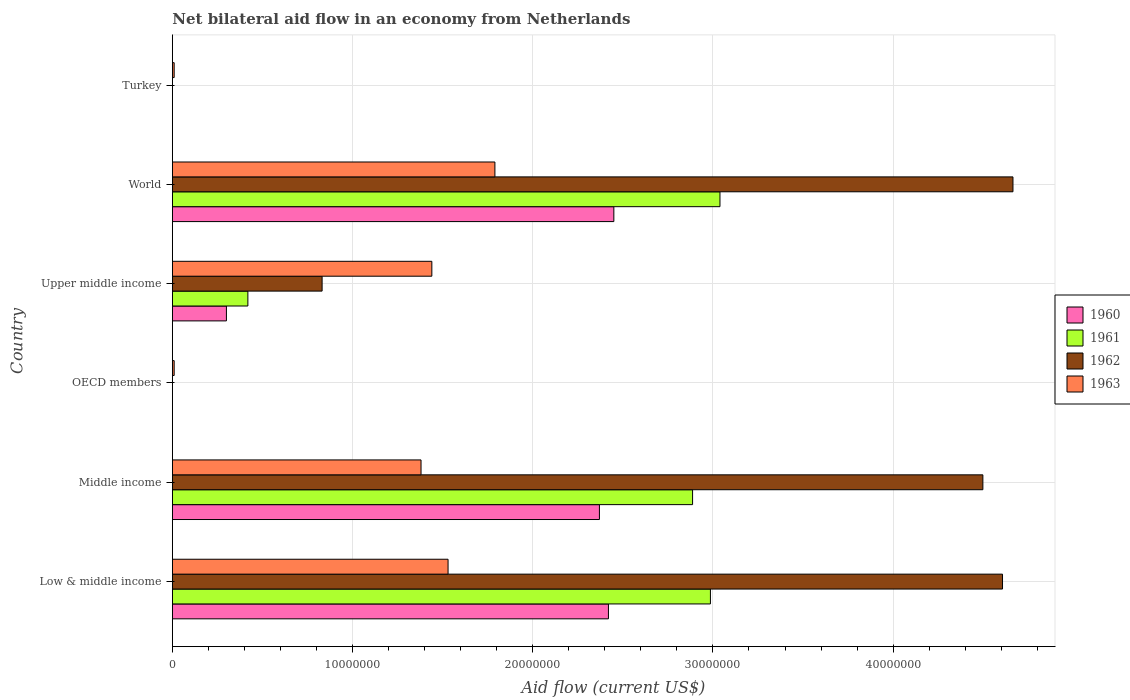Are the number of bars per tick equal to the number of legend labels?
Provide a succinct answer. No. Are the number of bars on each tick of the Y-axis equal?
Offer a terse response. No. How many bars are there on the 4th tick from the top?
Your answer should be compact. 1. How many bars are there on the 1st tick from the bottom?
Your answer should be very brief. 4. What is the label of the 4th group of bars from the top?
Offer a very short reply. OECD members. What is the net bilateral aid flow in 1963 in Turkey?
Provide a short and direct response. 1.00e+05. Across all countries, what is the maximum net bilateral aid flow in 1961?
Make the answer very short. 3.04e+07. What is the total net bilateral aid flow in 1962 in the graph?
Ensure brevity in your answer.  1.46e+08. What is the difference between the net bilateral aid flow in 1961 in Low & middle income and that in Upper middle income?
Offer a very short reply. 2.57e+07. What is the difference between the net bilateral aid flow in 1961 in Turkey and the net bilateral aid flow in 1963 in Middle income?
Keep it short and to the point. -1.38e+07. What is the average net bilateral aid flow in 1962 per country?
Offer a terse response. 2.43e+07. What is the difference between the net bilateral aid flow in 1960 and net bilateral aid flow in 1962 in World?
Provide a succinct answer. -2.22e+07. What is the ratio of the net bilateral aid flow in 1963 in Low & middle income to that in Turkey?
Offer a very short reply. 153. Is the net bilateral aid flow in 1963 in OECD members less than that in Upper middle income?
Provide a short and direct response. Yes. Is the difference between the net bilateral aid flow in 1960 in Middle income and Upper middle income greater than the difference between the net bilateral aid flow in 1962 in Middle income and Upper middle income?
Provide a short and direct response. No. What is the difference between the highest and the second highest net bilateral aid flow in 1963?
Provide a succinct answer. 2.60e+06. What is the difference between the highest and the lowest net bilateral aid flow in 1960?
Your answer should be very brief. 2.45e+07. In how many countries, is the net bilateral aid flow in 1962 greater than the average net bilateral aid flow in 1962 taken over all countries?
Give a very brief answer. 3. Is it the case that in every country, the sum of the net bilateral aid flow in 1963 and net bilateral aid flow in 1962 is greater than the sum of net bilateral aid flow in 1961 and net bilateral aid flow in 1960?
Offer a very short reply. No. How many bars are there?
Give a very brief answer. 18. How many countries are there in the graph?
Provide a short and direct response. 6. What is the difference between two consecutive major ticks on the X-axis?
Your answer should be compact. 1.00e+07. How many legend labels are there?
Make the answer very short. 4. What is the title of the graph?
Provide a succinct answer. Net bilateral aid flow in an economy from Netherlands. Does "2013" appear as one of the legend labels in the graph?
Keep it short and to the point. No. What is the label or title of the Y-axis?
Provide a short and direct response. Country. What is the Aid flow (current US$) in 1960 in Low & middle income?
Ensure brevity in your answer.  2.42e+07. What is the Aid flow (current US$) of 1961 in Low & middle income?
Make the answer very short. 2.99e+07. What is the Aid flow (current US$) of 1962 in Low & middle income?
Offer a terse response. 4.61e+07. What is the Aid flow (current US$) in 1963 in Low & middle income?
Make the answer very short. 1.53e+07. What is the Aid flow (current US$) in 1960 in Middle income?
Your response must be concise. 2.37e+07. What is the Aid flow (current US$) of 1961 in Middle income?
Give a very brief answer. 2.89e+07. What is the Aid flow (current US$) in 1962 in Middle income?
Ensure brevity in your answer.  4.50e+07. What is the Aid flow (current US$) in 1963 in Middle income?
Give a very brief answer. 1.38e+07. What is the Aid flow (current US$) in 1960 in OECD members?
Ensure brevity in your answer.  0. What is the Aid flow (current US$) in 1963 in OECD members?
Provide a succinct answer. 1.00e+05. What is the Aid flow (current US$) in 1961 in Upper middle income?
Provide a succinct answer. 4.19e+06. What is the Aid flow (current US$) of 1962 in Upper middle income?
Your answer should be compact. 8.31e+06. What is the Aid flow (current US$) of 1963 in Upper middle income?
Your answer should be compact. 1.44e+07. What is the Aid flow (current US$) in 1960 in World?
Your answer should be very brief. 2.45e+07. What is the Aid flow (current US$) in 1961 in World?
Offer a very short reply. 3.04e+07. What is the Aid flow (current US$) in 1962 in World?
Give a very brief answer. 4.66e+07. What is the Aid flow (current US$) of 1963 in World?
Provide a short and direct response. 1.79e+07. What is the Aid flow (current US$) of 1960 in Turkey?
Keep it short and to the point. 0. Across all countries, what is the maximum Aid flow (current US$) in 1960?
Offer a terse response. 2.45e+07. Across all countries, what is the maximum Aid flow (current US$) in 1961?
Your response must be concise. 3.04e+07. Across all countries, what is the maximum Aid flow (current US$) of 1962?
Your answer should be very brief. 4.66e+07. Across all countries, what is the maximum Aid flow (current US$) in 1963?
Provide a short and direct response. 1.79e+07. Across all countries, what is the minimum Aid flow (current US$) of 1961?
Keep it short and to the point. 0. Across all countries, what is the minimum Aid flow (current US$) in 1962?
Your answer should be compact. 0. What is the total Aid flow (current US$) of 1960 in the graph?
Your answer should be compact. 7.54e+07. What is the total Aid flow (current US$) of 1961 in the graph?
Give a very brief answer. 9.33e+07. What is the total Aid flow (current US$) of 1962 in the graph?
Your answer should be very brief. 1.46e+08. What is the total Aid flow (current US$) in 1963 in the graph?
Provide a short and direct response. 6.16e+07. What is the difference between the Aid flow (current US$) of 1960 in Low & middle income and that in Middle income?
Ensure brevity in your answer.  5.00e+05. What is the difference between the Aid flow (current US$) in 1961 in Low & middle income and that in Middle income?
Make the answer very short. 9.90e+05. What is the difference between the Aid flow (current US$) of 1962 in Low & middle income and that in Middle income?
Make the answer very short. 1.09e+06. What is the difference between the Aid flow (current US$) of 1963 in Low & middle income and that in Middle income?
Your response must be concise. 1.50e+06. What is the difference between the Aid flow (current US$) of 1963 in Low & middle income and that in OECD members?
Provide a succinct answer. 1.52e+07. What is the difference between the Aid flow (current US$) in 1960 in Low & middle income and that in Upper middle income?
Ensure brevity in your answer.  2.12e+07. What is the difference between the Aid flow (current US$) of 1961 in Low & middle income and that in Upper middle income?
Offer a terse response. 2.57e+07. What is the difference between the Aid flow (current US$) of 1962 in Low & middle income and that in Upper middle income?
Offer a very short reply. 3.78e+07. What is the difference between the Aid flow (current US$) in 1960 in Low & middle income and that in World?
Keep it short and to the point. -3.00e+05. What is the difference between the Aid flow (current US$) of 1961 in Low & middle income and that in World?
Make the answer very short. -5.30e+05. What is the difference between the Aid flow (current US$) of 1962 in Low & middle income and that in World?
Provide a short and direct response. -5.80e+05. What is the difference between the Aid flow (current US$) in 1963 in Low & middle income and that in World?
Give a very brief answer. -2.60e+06. What is the difference between the Aid flow (current US$) in 1963 in Low & middle income and that in Turkey?
Offer a very short reply. 1.52e+07. What is the difference between the Aid flow (current US$) in 1963 in Middle income and that in OECD members?
Your answer should be very brief. 1.37e+07. What is the difference between the Aid flow (current US$) of 1960 in Middle income and that in Upper middle income?
Your answer should be very brief. 2.07e+07. What is the difference between the Aid flow (current US$) in 1961 in Middle income and that in Upper middle income?
Offer a terse response. 2.47e+07. What is the difference between the Aid flow (current US$) of 1962 in Middle income and that in Upper middle income?
Your answer should be very brief. 3.67e+07. What is the difference between the Aid flow (current US$) in 1963 in Middle income and that in Upper middle income?
Your response must be concise. -6.00e+05. What is the difference between the Aid flow (current US$) of 1960 in Middle income and that in World?
Give a very brief answer. -8.00e+05. What is the difference between the Aid flow (current US$) in 1961 in Middle income and that in World?
Ensure brevity in your answer.  -1.52e+06. What is the difference between the Aid flow (current US$) in 1962 in Middle income and that in World?
Keep it short and to the point. -1.67e+06. What is the difference between the Aid flow (current US$) of 1963 in Middle income and that in World?
Provide a short and direct response. -4.10e+06. What is the difference between the Aid flow (current US$) in 1963 in Middle income and that in Turkey?
Your answer should be very brief. 1.37e+07. What is the difference between the Aid flow (current US$) of 1963 in OECD members and that in Upper middle income?
Ensure brevity in your answer.  -1.43e+07. What is the difference between the Aid flow (current US$) in 1963 in OECD members and that in World?
Your answer should be very brief. -1.78e+07. What is the difference between the Aid flow (current US$) of 1963 in OECD members and that in Turkey?
Keep it short and to the point. 0. What is the difference between the Aid flow (current US$) in 1960 in Upper middle income and that in World?
Your response must be concise. -2.15e+07. What is the difference between the Aid flow (current US$) in 1961 in Upper middle income and that in World?
Offer a very short reply. -2.62e+07. What is the difference between the Aid flow (current US$) of 1962 in Upper middle income and that in World?
Make the answer very short. -3.83e+07. What is the difference between the Aid flow (current US$) in 1963 in Upper middle income and that in World?
Provide a succinct answer. -3.50e+06. What is the difference between the Aid flow (current US$) in 1963 in Upper middle income and that in Turkey?
Provide a short and direct response. 1.43e+07. What is the difference between the Aid flow (current US$) in 1963 in World and that in Turkey?
Your response must be concise. 1.78e+07. What is the difference between the Aid flow (current US$) in 1960 in Low & middle income and the Aid flow (current US$) in 1961 in Middle income?
Make the answer very short. -4.67e+06. What is the difference between the Aid flow (current US$) of 1960 in Low & middle income and the Aid flow (current US$) of 1962 in Middle income?
Provide a short and direct response. -2.08e+07. What is the difference between the Aid flow (current US$) of 1960 in Low & middle income and the Aid flow (current US$) of 1963 in Middle income?
Provide a short and direct response. 1.04e+07. What is the difference between the Aid flow (current US$) in 1961 in Low & middle income and the Aid flow (current US$) in 1962 in Middle income?
Your answer should be compact. -1.51e+07. What is the difference between the Aid flow (current US$) in 1961 in Low & middle income and the Aid flow (current US$) in 1963 in Middle income?
Keep it short and to the point. 1.61e+07. What is the difference between the Aid flow (current US$) in 1962 in Low & middle income and the Aid flow (current US$) in 1963 in Middle income?
Offer a very short reply. 3.23e+07. What is the difference between the Aid flow (current US$) in 1960 in Low & middle income and the Aid flow (current US$) in 1963 in OECD members?
Your response must be concise. 2.41e+07. What is the difference between the Aid flow (current US$) of 1961 in Low & middle income and the Aid flow (current US$) of 1963 in OECD members?
Provide a succinct answer. 2.98e+07. What is the difference between the Aid flow (current US$) of 1962 in Low & middle income and the Aid flow (current US$) of 1963 in OECD members?
Your response must be concise. 4.60e+07. What is the difference between the Aid flow (current US$) in 1960 in Low & middle income and the Aid flow (current US$) in 1961 in Upper middle income?
Make the answer very short. 2.00e+07. What is the difference between the Aid flow (current US$) of 1960 in Low & middle income and the Aid flow (current US$) of 1962 in Upper middle income?
Keep it short and to the point. 1.59e+07. What is the difference between the Aid flow (current US$) in 1960 in Low & middle income and the Aid flow (current US$) in 1963 in Upper middle income?
Your answer should be compact. 9.80e+06. What is the difference between the Aid flow (current US$) of 1961 in Low & middle income and the Aid flow (current US$) of 1962 in Upper middle income?
Offer a very short reply. 2.16e+07. What is the difference between the Aid flow (current US$) in 1961 in Low & middle income and the Aid flow (current US$) in 1963 in Upper middle income?
Keep it short and to the point. 1.55e+07. What is the difference between the Aid flow (current US$) of 1962 in Low & middle income and the Aid flow (current US$) of 1963 in Upper middle income?
Offer a very short reply. 3.17e+07. What is the difference between the Aid flow (current US$) of 1960 in Low & middle income and the Aid flow (current US$) of 1961 in World?
Offer a terse response. -6.19e+06. What is the difference between the Aid flow (current US$) in 1960 in Low & middle income and the Aid flow (current US$) in 1962 in World?
Provide a short and direct response. -2.24e+07. What is the difference between the Aid flow (current US$) of 1960 in Low & middle income and the Aid flow (current US$) of 1963 in World?
Ensure brevity in your answer.  6.30e+06. What is the difference between the Aid flow (current US$) in 1961 in Low & middle income and the Aid flow (current US$) in 1962 in World?
Ensure brevity in your answer.  -1.68e+07. What is the difference between the Aid flow (current US$) in 1961 in Low & middle income and the Aid flow (current US$) in 1963 in World?
Your answer should be compact. 1.20e+07. What is the difference between the Aid flow (current US$) in 1962 in Low & middle income and the Aid flow (current US$) in 1963 in World?
Offer a very short reply. 2.82e+07. What is the difference between the Aid flow (current US$) of 1960 in Low & middle income and the Aid flow (current US$) of 1963 in Turkey?
Ensure brevity in your answer.  2.41e+07. What is the difference between the Aid flow (current US$) of 1961 in Low & middle income and the Aid flow (current US$) of 1963 in Turkey?
Your response must be concise. 2.98e+07. What is the difference between the Aid flow (current US$) in 1962 in Low & middle income and the Aid flow (current US$) in 1963 in Turkey?
Your answer should be compact. 4.60e+07. What is the difference between the Aid flow (current US$) in 1960 in Middle income and the Aid flow (current US$) in 1963 in OECD members?
Keep it short and to the point. 2.36e+07. What is the difference between the Aid flow (current US$) in 1961 in Middle income and the Aid flow (current US$) in 1963 in OECD members?
Keep it short and to the point. 2.88e+07. What is the difference between the Aid flow (current US$) in 1962 in Middle income and the Aid flow (current US$) in 1963 in OECD members?
Your answer should be compact. 4.49e+07. What is the difference between the Aid flow (current US$) in 1960 in Middle income and the Aid flow (current US$) in 1961 in Upper middle income?
Provide a succinct answer. 1.95e+07. What is the difference between the Aid flow (current US$) of 1960 in Middle income and the Aid flow (current US$) of 1962 in Upper middle income?
Provide a short and direct response. 1.54e+07. What is the difference between the Aid flow (current US$) of 1960 in Middle income and the Aid flow (current US$) of 1963 in Upper middle income?
Your answer should be compact. 9.30e+06. What is the difference between the Aid flow (current US$) in 1961 in Middle income and the Aid flow (current US$) in 1962 in Upper middle income?
Your answer should be very brief. 2.06e+07. What is the difference between the Aid flow (current US$) of 1961 in Middle income and the Aid flow (current US$) of 1963 in Upper middle income?
Make the answer very short. 1.45e+07. What is the difference between the Aid flow (current US$) of 1962 in Middle income and the Aid flow (current US$) of 1963 in Upper middle income?
Your answer should be compact. 3.06e+07. What is the difference between the Aid flow (current US$) in 1960 in Middle income and the Aid flow (current US$) in 1961 in World?
Your answer should be compact. -6.69e+06. What is the difference between the Aid flow (current US$) in 1960 in Middle income and the Aid flow (current US$) in 1962 in World?
Offer a terse response. -2.30e+07. What is the difference between the Aid flow (current US$) in 1960 in Middle income and the Aid flow (current US$) in 1963 in World?
Make the answer very short. 5.80e+06. What is the difference between the Aid flow (current US$) in 1961 in Middle income and the Aid flow (current US$) in 1962 in World?
Make the answer very short. -1.78e+07. What is the difference between the Aid flow (current US$) of 1961 in Middle income and the Aid flow (current US$) of 1963 in World?
Make the answer very short. 1.10e+07. What is the difference between the Aid flow (current US$) in 1962 in Middle income and the Aid flow (current US$) in 1963 in World?
Give a very brief answer. 2.71e+07. What is the difference between the Aid flow (current US$) in 1960 in Middle income and the Aid flow (current US$) in 1963 in Turkey?
Your response must be concise. 2.36e+07. What is the difference between the Aid flow (current US$) in 1961 in Middle income and the Aid flow (current US$) in 1963 in Turkey?
Provide a short and direct response. 2.88e+07. What is the difference between the Aid flow (current US$) in 1962 in Middle income and the Aid flow (current US$) in 1963 in Turkey?
Provide a succinct answer. 4.49e+07. What is the difference between the Aid flow (current US$) of 1960 in Upper middle income and the Aid flow (current US$) of 1961 in World?
Make the answer very short. -2.74e+07. What is the difference between the Aid flow (current US$) in 1960 in Upper middle income and the Aid flow (current US$) in 1962 in World?
Offer a very short reply. -4.36e+07. What is the difference between the Aid flow (current US$) of 1960 in Upper middle income and the Aid flow (current US$) of 1963 in World?
Your response must be concise. -1.49e+07. What is the difference between the Aid flow (current US$) in 1961 in Upper middle income and the Aid flow (current US$) in 1962 in World?
Offer a very short reply. -4.25e+07. What is the difference between the Aid flow (current US$) in 1961 in Upper middle income and the Aid flow (current US$) in 1963 in World?
Keep it short and to the point. -1.37e+07. What is the difference between the Aid flow (current US$) in 1962 in Upper middle income and the Aid flow (current US$) in 1963 in World?
Ensure brevity in your answer.  -9.59e+06. What is the difference between the Aid flow (current US$) in 1960 in Upper middle income and the Aid flow (current US$) in 1963 in Turkey?
Ensure brevity in your answer.  2.90e+06. What is the difference between the Aid flow (current US$) of 1961 in Upper middle income and the Aid flow (current US$) of 1963 in Turkey?
Make the answer very short. 4.09e+06. What is the difference between the Aid flow (current US$) in 1962 in Upper middle income and the Aid flow (current US$) in 1963 in Turkey?
Keep it short and to the point. 8.21e+06. What is the difference between the Aid flow (current US$) in 1960 in World and the Aid flow (current US$) in 1963 in Turkey?
Keep it short and to the point. 2.44e+07. What is the difference between the Aid flow (current US$) in 1961 in World and the Aid flow (current US$) in 1963 in Turkey?
Offer a terse response. 3.03e+07. What is the difference between the Aid flow (current US$) of 1962 in World and the Aid flow (current US$) of 1963 in Turkey?
Your response must be concise. 4.66e+07. What is the average Aid flow (current US$) of 1960 per country?
Provide a short and direct response. 1.26e+07. What is the average Aid flow (current US$) of 1961 per country?
Your answer should be very brief. 1.56e+07. What is the average Aid flow (current US$) of 1962 per country?
Make the answer very short. 2.43e+07. What is the average Aid flow (current US$) in 1963 per country?
Give a very brief answer. 1.03e+07. What is the difference between the Aid flow (current US$) in 1960 and Aid flow (current US$) in 1961 in Low & middle income?
Provide a succinct answer. -5.66e+06. What is the difference between the Aid flow (current US$) in 1960 and Aid flow (current US$) in 1962 in Low & middle income?
Your answer should be compact. -2.19e+07. What is the difference between the Aid flow (current US$) of 1960 and Aid flow (current US$) of 1963 in Low & middle income?
Make the answer very short. 8.90e+06. What is the difference between the Aid flow (current US$) in 1961 and Aid flow (current US$) in 1962 in Low & middle income?
Give a very brief answer. -1.62e+07. What is the difference between the Aid flow (current US$) of 1961 and Aid flow (current US$) of 1963 in Low & middle income?
Offer a very short reply. 1.46e+07. What is the difference between the Aid flow (current US$) of 1962 and Aid flow (current US$) of 1963 in Low & middle income?
Provide a short and direct response. 3.08e+07. What is the difference between the Aid flow (current US$) in 1960 and Aid flow (current US$) in 1961 in Middle income?
Offer a very short reply. -5.17e+06. What is the difference between the Aid flow (current US$) of 1960 and Aid flow (current US$) of 1962 in Middle income?
Your answer should be very brief. -2.13e+07. What is the difference between the Aid flow (current US$) of 1960 and Aid flow (current US$) of 1963 in Middle income?
Provide a short and direct response. 9.90e+06. What is the difference between the Aid flow (current US$) of 1961 and Aid flow (current US$) of 1962 in Middle income?
Offer a very short reply. -1.61e+07. What is the difference between the Aid flow (current US$) in 1961 and Aid flow (current US$) in 1963 in Middle income?
Provide a short and direct response. 1.51e+07. What is the difference between the Aid flow (current US$) of 1962 and Aid flow (current US$) of 1963 in Middle income?
Your answer should be very brief. 3.12e+07. What is the difference between the Aid flow (current US$) in 1960 and Aid flow (current US$) in 1961 in Upper middle income?
Make the answer very short. -1.19e+06. What is the difference between the Aid flow (current US$) in 1960 and Aid flow (current US$) in 1962 in Upper middle income?
Your answer should be very brief. -5.31e+06. What is the difference between the Aid flow (current US$) in 1960 and Aid flow (current US$) in 1963 in Upper middle income?
Ensure brevity in your answer.  -1.14e+07. What is the difference between the Aid flow (current US$) of 1961 and Aid flow (current US$) of 1962 in Upper middle income?
Keep it short and to the point. -4.12e+06. What is the difference between the Aid flow (current US$) in 1961 and Aid flow (current US$) in 1963 in Upper middle income?
Make the answer very short. -1.02e+07. What is the difference between the Aid flow (current US$) of 1962 and Aid flow (current US$) of 1963 in Upper middle income?
Provide a succinct answer. -6.09e+06. What is the difference between the Aid flow (current US$) in 1960 and Aid flow (current US$) in 1961 in World?
Ensure brevity in your answer.  -5.89e+06. What is the difference between the Aid flow (current US$) in 1960 and Aid flow (current US$) in 1962 in World?
Give a very brief answer. -2.22e+07. What is the difference between the Aid flow (current US$) of 1960 and Aid flow (current US$) of 1963 in World?
Your answer should be compact. 6.60e+06. What is the difference between the Aid flow (current US$) of 1961 and Aid flow (current US$) of 1962 in World?
Offer a terse response. -1.63e+07. What is the difference between the Aid flow (current US$) in 1961 and Aid flow (current US$) in 1963 in World?
Provide a short and direct response. 1.25e+07. What is the difference between the Aid flow (current US$) of 1962 and Aid flow (current US$) of 1963 in World?
Your answer should be very brief. 2.88e+07. What is the ratio of the Aid flow (current US$) in 1960 in Low & middle income to that in Middle income?
Keep it short and to the point. 1.02. What is the ratio of the Aid flow (current US$) in 1961 in Low & middle income to that in Middle income?
Your answer should be compact. 1.03. What is the ratio of the Aid flow (current US$) of 1962 in Low & middle income to that in Middle income?
Ensure brevity in your answer.  1.02. What is the ratio of the Aid flow (current US$) in 1963 in Low & middle income to that in Middle income?
Offer a very short reply. 1.11. What is the ratio of the Aid flow (current US$) in 1963 in Low & middle income to that in OECD members?
Offer a terse response. 153. What is the ratio of the Aid flow (current US$) in 1960 in Low & middle income to that in Upper middle income?
Your answer should be very brief. 8.07. What is the ratio of the Aid flow (current US$) in 1961 in Low & middle income to that in Upper middle income?
Your answer should be compact. 7.13. What is the ratio of the Aid flow (current US$) of 1962 in Low & middle income to that in Upper middle income?
Your response must be concise. 5.54. What is the ratio of the Aid flow (current US$) in 1963 in Low & middle income to that in Upper middle income?
Your response must be concise. 1.06. What is the ratio of the Aid flow (current US$) in 1961 in Low & middle income to that in World?
Provide a succinct answer. 0.98. What is the ratio of the Aid flow (current US$) of 1962 in Low & middle income to that in World?
Your answer should be very brief. 0.99. What is the ratio of the Aid flow (current US$) in 1963 in Low & middle income to that in World?
Your answer should be very brief. 0.85. What is the ratio of the Aid flow (current US$) in 1963 in Low & middle income to that in Turkey?
Offer a terse response. 153. What is the ratio of the Aid flow (current US$) in 1963 in Middle income to that in OECD members?
Your answer should be very brief. 138. What is the ratio of the Aid flow (current US$) in 1960 in Middle income to that in Upper middle income?
Your answer should be compact. 7.9. What is the ratio of the Aid flow (current US$) of 1961 in Middle income to that in Upper middle income?
Give a very brief answer. 6.89. What is the ratio of the Aid flow (current US$) in 1962 in Middle income to that in Upper middle income?
Offer a terse response. 5.41. What is the ratio of the Aid flow (current US$) of 1963 in Middle income to that in Upper middle income?
Offer a very short reply. 0.96. What is the ratio of the Aid flow (current US$) of 1960 in Middle income to that in World?
Give a very brief answer. 0.97. What is the ratio of the Aid flow (current US$) in 1961 in Middle income to that in World?
Your response must be concise. 0.95. What is the ratio of the Aid flow (current US$) in 1962 in Middle income to that in World?
Give a very brief answer. 0.96. What is the ratio of the Aid flow (current US$) in 1963 in Middle income to that in World?
Keep it short and to the point. 0.77. What is the ratio of the Aid flow (current US$) of 1963 in Middle income to that in Turkey?
Make the answer very short. 138. What is the ratio of the Aid flow (current US$) in 1963 in OECD members to that in Upper middle income?
Offer a terse response. 0.01. What is the ratio of the Aid flow (current US$) of 1963 in OECD members to that in World?
Provide a succinct answer. 0.01. What is the ratio of the Aid flow (current US$) in 1960 in Upper middle income to that in World?
Keep it short and to the point. 0.12. What is the ratio of the Aid flow (current US$) in 1961 in Upper middle income to that in World?
Make the answer very short. 0.14. What is the ratio of the Aid flow (current US$) in 1962 in Upper middle income to that in World?
Give a very brief answer. 0.18. What is the ratio of the Aid flow (current US$) in 1963 in Upper middle income to that in World?
Give a very brief answer. 0.8. What is the ratio of the Aid flow (current US$) in 1963 in Upper middle income to that in Turkey?
Your answer should be very brief. 144. What is the ratio of the Aid flow (current US$) of 1963 in World to that in Turkey?
Offer a terse response. 179. What is the difference between the highest and the second highest Aid flow (current US$) in 1961?
Your answer should be very brief. 5.30e+05. What is the difference between the highest and the second highest Aid flow (current US$) of 1962?
Give a very brief answer. 5.80e+05. What is the difference between the highest and the second highest Aid flow (current US$) of 1963?
Give a very brief answer. 2.60e+06. What is the difference between the highest and the lowest Aid flow (current US$) in 1960?
Provide a succinct answer. 2.45e+07. What is the difference between the highest and the lowest Aid flow (current US$) in 1961?
Your answer should be compact. 3.04e+07. What is the difference between the highest and the lowest Aid flow (current US$) of 1962?
Your answer should be compact. 4.66e+07. What is the difference between the highest and the lowest Aid flow (current US$) of 1963?
Your response must be concise. 1.78e+07. 